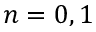<formula> <loc_0><loc_0><loc_500><loc_500>n = 0 , 1</formula> 